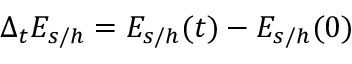Convert formula to latex. <formula><loc_0><loc_0><loc_500><loc_500>\Delta _ { t } E _ { s / h } = E _ { s / h } ( t ) - E _ { s / h } ( 0 )</formula> 